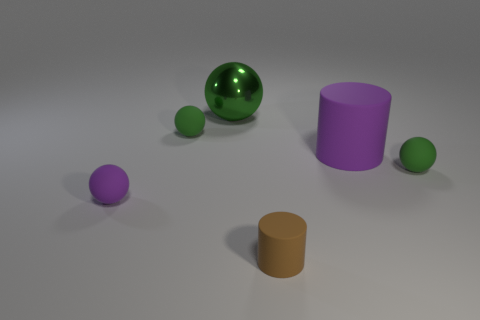There is a ball that is on the right side of the big purple rubber cylinder; does it have the same color as the large metallic thing?
Provide a short and direct response. Yes. There is another thing that is the same color as the large matte object; what shape is it?
Offer a terse response. Sphere. There is a tiny green object on the right side of the big green object behind the cylinder behind the small brown matte object; what shape is it?
Provide a short and direct response. Sphere. What is the shape of the purple object to the right of the small purple rubber thing?
Your answer should be compact. Cylinder. Is the big ball made of the same material as the big purple cylinder that is to the right of the big green object?
Offer a terse response. No. What number of other things are the same shape as the large green thing?
Your response must be concise. 3. Does the big metallic thing have the same color as the rubber sphere behind the large cylinder?
Provide a succinct answer. Yes. Is there anything else that has the same material as the big ball?
Offer a terse response. No. There is a tiny green thing that is right of the cylinder in front of the purple sphere; what is its shape?
Make the answer very short. Sphere. What size is the sphere that is the same color as the big rubber cylinder?
Give a very brief answer. Small. 